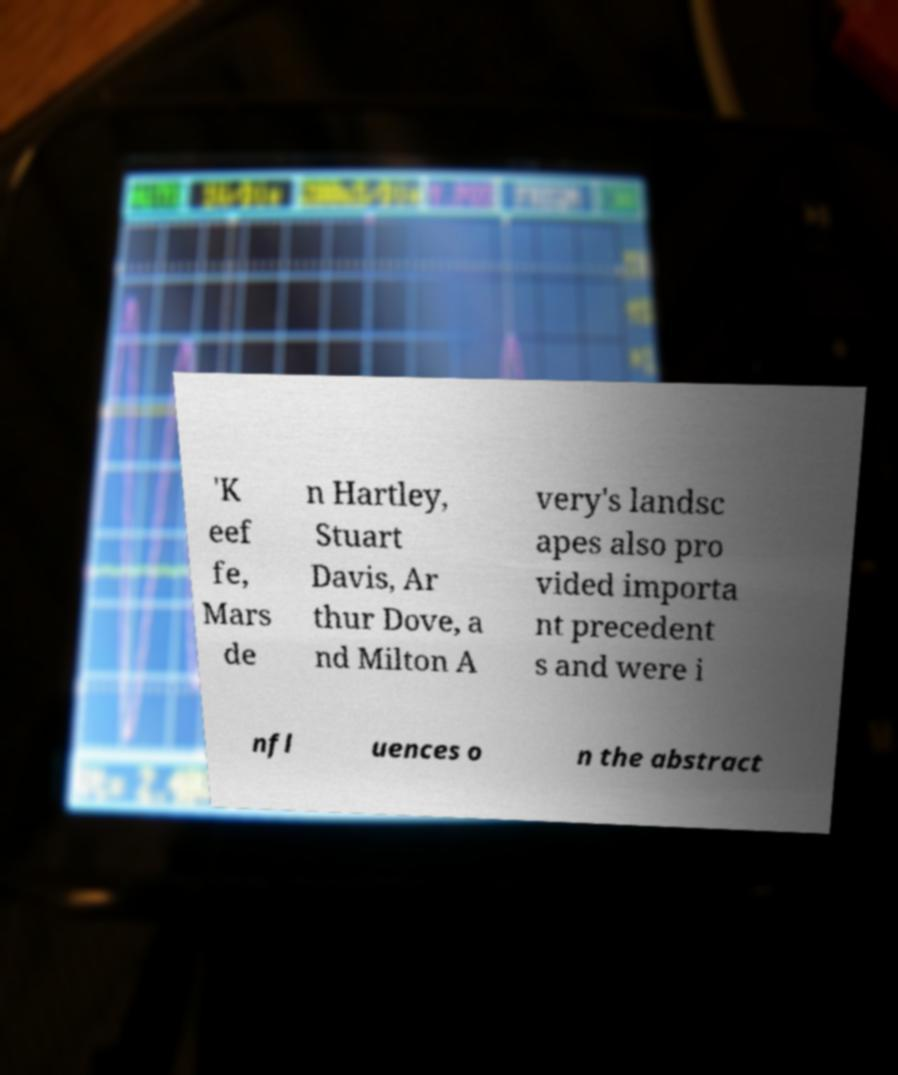Could you assist in decoding the text presented in this image and type it out clearly? 'K eef fe, Mars de n Hartley, Stuart Davis, Ar thur Dove, a nd Milton A very's landsc apes also pro vided importa nt precedent s and were i nfl uences o n the abstract 